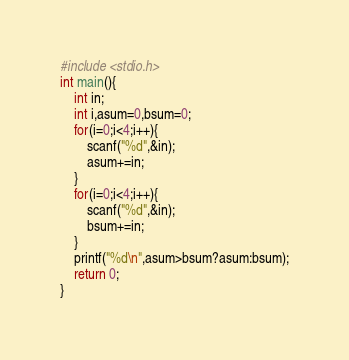<code> <loc_0><loc_0><loc_500><loc_500><_C_>#include <stdio.h>
int main(){
	int in;
	int i,asum=0,bsum=0;
	for(i=0;i<4;i++){
		scanf("%d",&in);
		asum+=in;
	}
	for(i=0;i<4;i++){
		scanf("%d",&in);
		bsum+=in;
	}
	printf("%d\n",asum>bsum?asum:bsum);
	return 0;
}</code> 